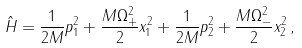<formula> <loc_0><loc_0><loc_500><loc_500>\hat { H } = \frac { 1 } { 2 M } p _ { 1 } ^ { 2 } + \frac { M \Omega _ { + } ^ { 2 } } { 2 } x _ { 1 } ^ { 2 } + \frac { 1 } { 2 M } p _ { 2 } ^ { 2 } + \frac { M \Omega _ { - } ^ { 2 } } { 2 } x _ { 2 } ^ { 2 } \, ,</formula> 